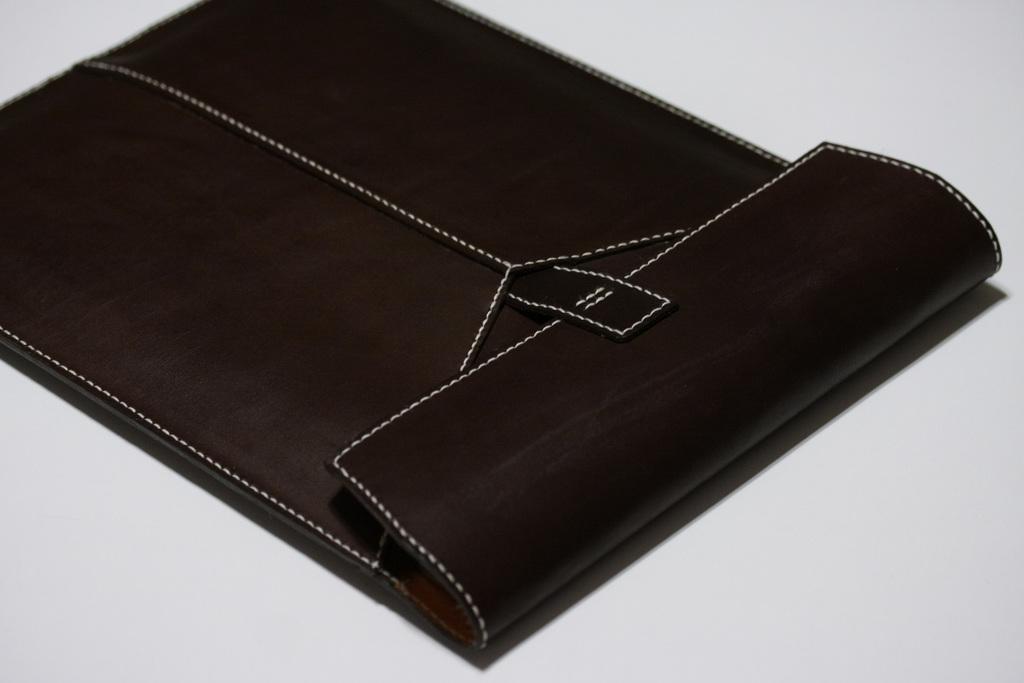Please provide a concise description of this image. In this image I see a brown color thing which is on the white color surface. 